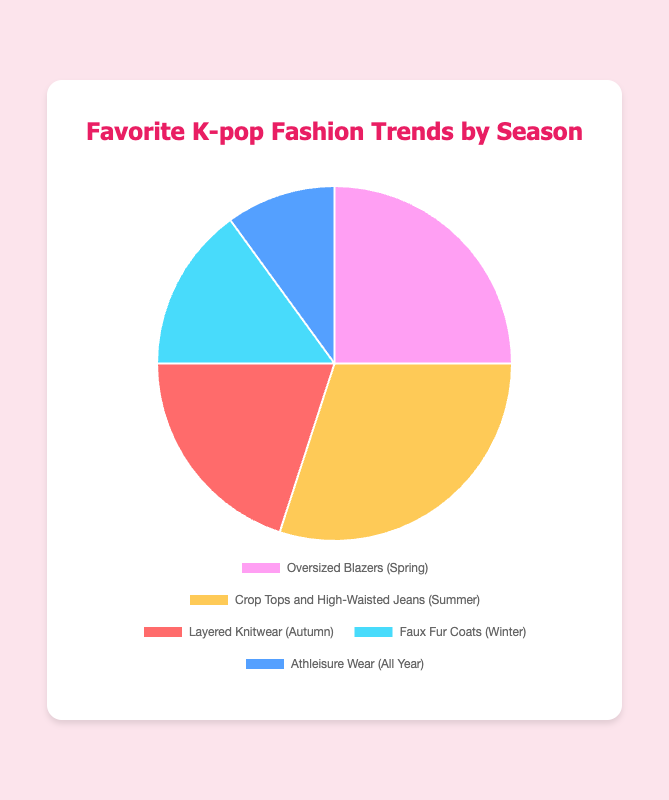Which K-pop fashion trend is the most popular for summer? The visual pie chart shows that "Crop Tops and High-Waisted Jeans" is associated with summer and occupies the largest sector, or 30% of the pie.
Answer: Crop Tops and High-Waisted Jeans What is the combined percentage of trends popular in autumn and winter? The trend "Layered Knitwear" has 20% in autumn and "Faux Fur Coats" has 15% in winter. Adding these percentages gives 20% + 15% = 35%.
Answer: 35% Which trend appears to be popular all year round? By examining the labels in the pie chart, "Athleisure Wear" is indicated for all-year-round, occupying a section of the pie.
Answer: Athleisure Wear Compare the popularity of winter trends to spring trends. Which is more favored? The chart shows that "Faux Fur Coats" for winter is 15%, and "Oversized Blazers" for spring is 25%. Since 25% > 15%, spring trends are more favored.
Answer: Spring trends If "Crop Tops and High-Waisted Jeans" and "Athleisure Wear" are combined, what percentage of the pie chart would they take up? "Crop Tops and High-Waisted Jeans" occupy 30% and "Athleisure Wear" takes 10%. Adding these two percentages gives 30% + 10% = 40%.
Answer: 40% Which two trends together form half of the chart? "Crop Tops and High-Waisted Jeans" has 30% and "Oversized Blazers" has 25%. Adding these together gives 30% + 25% = 55%, which exceeds half. Checking next highest, "Crop Tops and High-Waisted Jeans" (30%) plus "Layered Knitwear" (20%) gives 30% + 20% = 50%.
Answer: Crop Tops and High-Waisted Jeans and Layered Knitwear What trend occupies the smallest portion of the pie chart? The visual inspection of the pie chart sectors shows that "Athleisure Wear" occupies the smallest portion at 10%.
Answer: Athleisure Wear How much more popular is the spring trend compared to the winter trend? "Oversized Blazers" in spring are at 25% and "Faux Fur Coats" in winter are at 15%. The difference is 25% - 15% = 10%.
Answer: 10% 